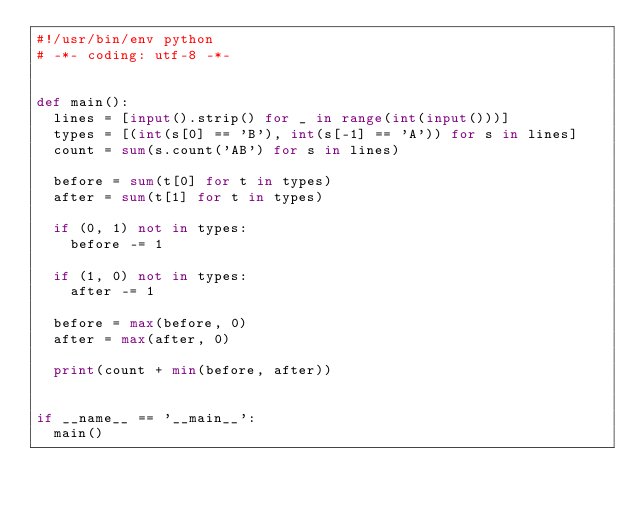<code> <loc_0><loc_0><loc_500><loc_500><_Python_>#!/usr/bin/env python
# -*- coding: utf-8 -*-


def main():
  lines = [input().strip() for _ in range(int(input()))]
  types = [(int(s[0] == 'B'), int(s[-1] == 'A')) for s in lines]
  count = sum(s.count('AB') for s in lines)

  before = sum(t[0] for t in types)
  after = sum(t[1] for t in types)

  if (0, 1) not in types:
    before -= 1

  if (1, 0) not in types:
    after -= 1

  before = max(before, 0)
  after = max(after, 0)

  print(count + min(before, after))


if __name__ == '__main__':
  main()

</code> 